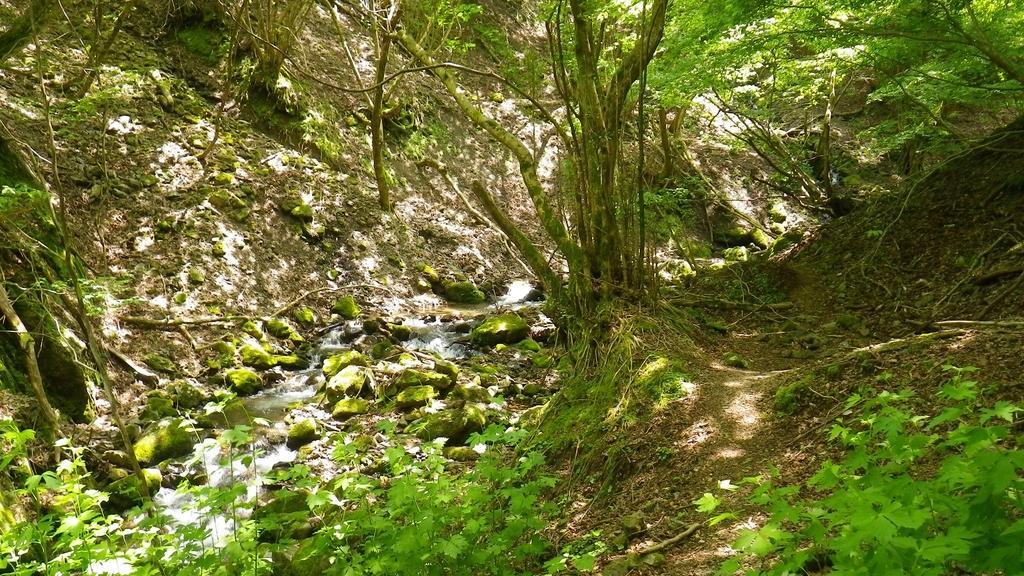Could you give a brief overview of what you see in this image? In this picture we can see water, few rocks, plants and trees. 